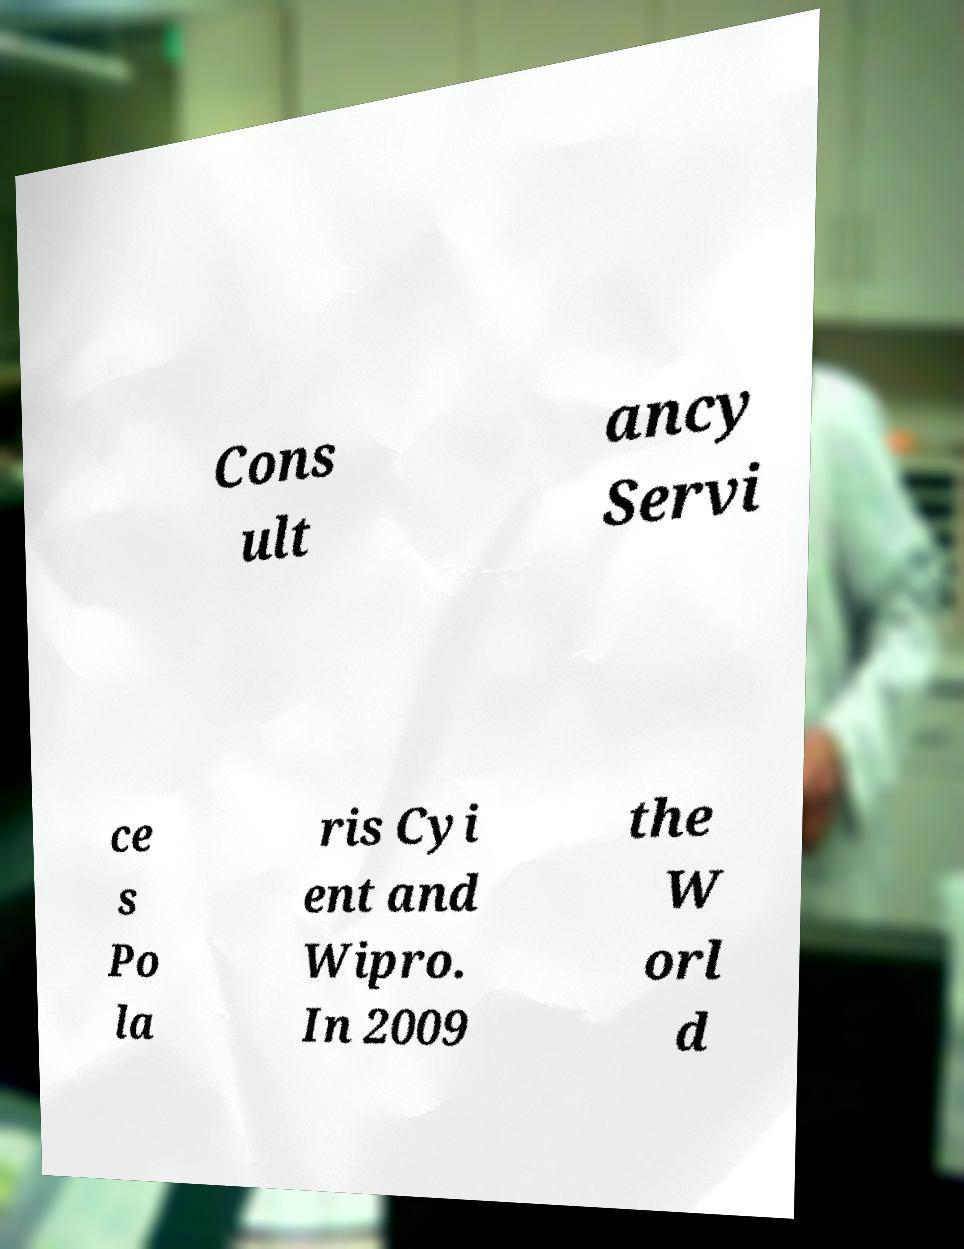Please read and relay the text visible in this image. What does it say? Cons ult ancy Servi ce s Po la ris Cyi ent and Wipro. In 2009 the W orl d 